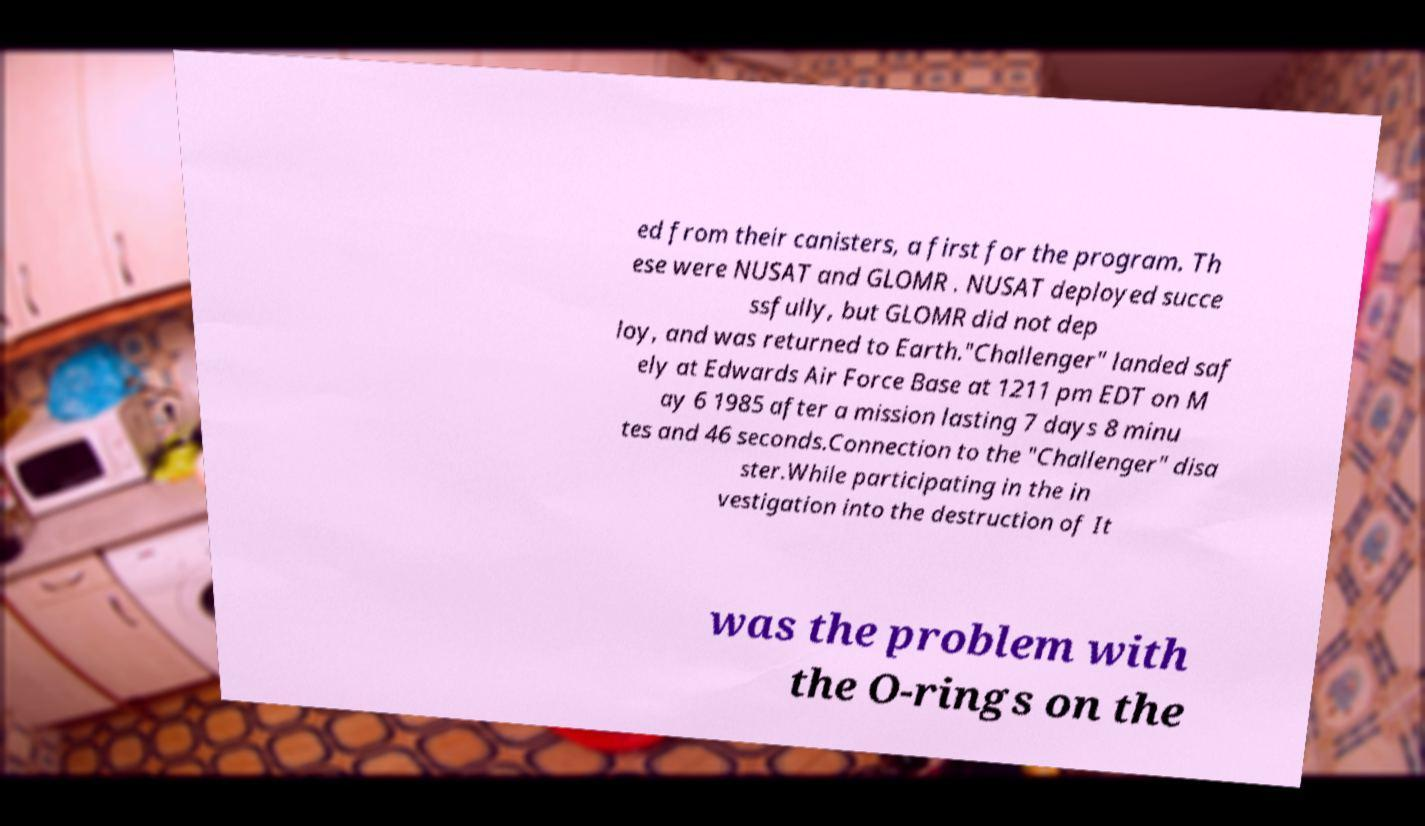Could you assist in decoding the text presented in this image and type it out clearly? ed from their canisters, a first for the program. Th ese were NUSAT and GLOMR . NUSAT deployed succe ssfully, but GLOMR did not dep loy, and was returned to Earth."Challenger" landed saf ely at Edwards Air Force Base at 1211 pm EDT on M ay 6 1985 after a mission lasting 7 days 8 minu tes and 46 seconds.Connection to the "Challenger" disa ster.While participating in the in vestigation into the destruction of It was the problem with the O-rings on the 